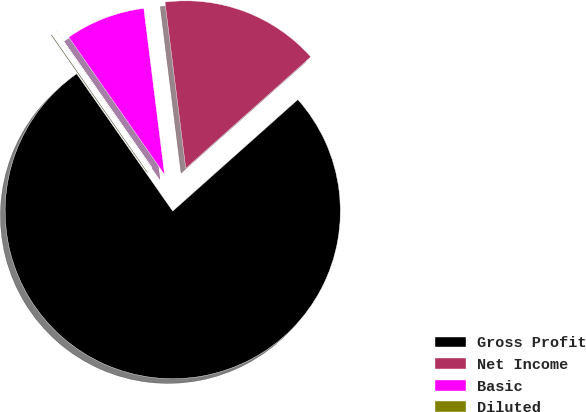<chart> <loc_0><loc_0><loc_500><loc_500><pie_chart><fcel>Gross Profit<fcel>Net Income<fcel>Basic<fcel>Diluted<nl><fcel>76.88%<fcel>15.39%<fcel>7.71%<fcel>0.02%<nl></chart> 